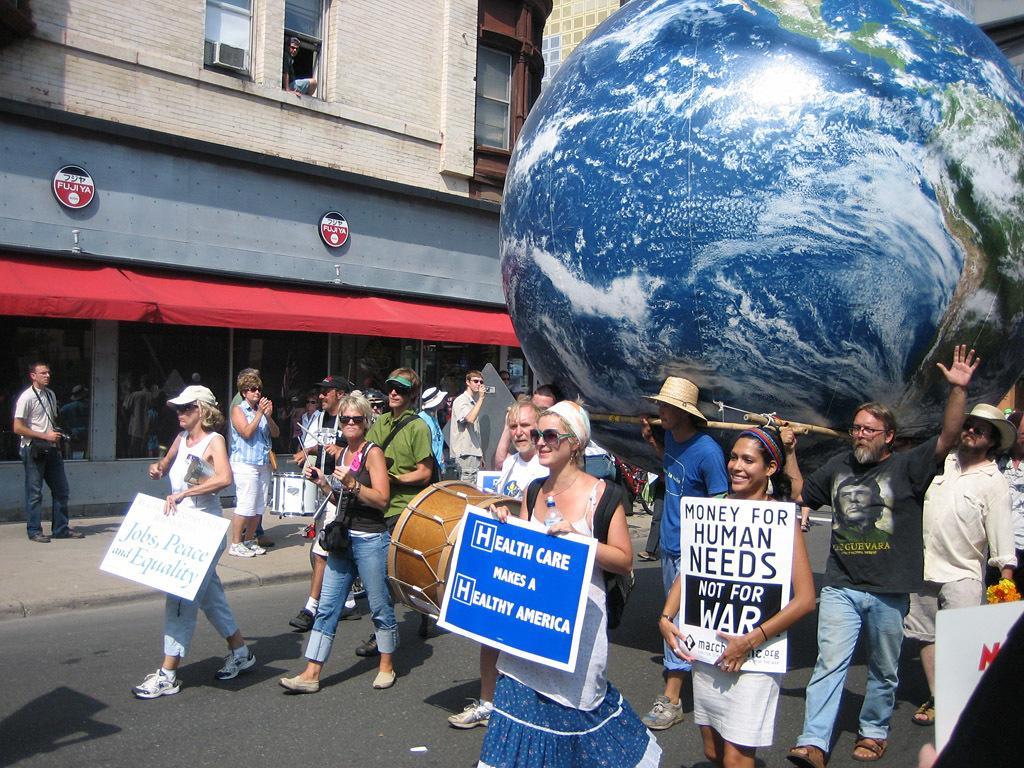Can you describe this image briefly? There are group of people walking. few people are holding placards and few people are playing musical instruments. This is a big ball with earth structure. This is a building with windows. This is the rooftop which is red in color. These are the windows of the building. 